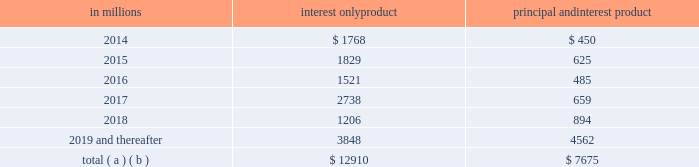Charge-off is based on pnc 2019s actual loss experience for each type of pool .
Since a pool may consist of first and second liens , the charge-off amounts for the pool are proportionate to the composition of first and second liens in the pool .
Our experience has been that the ratio of first to second lien loans has been consistent over time and is appropriately represented in our pools used for roll-rate calculations .
Generally , our variable-rate home equity lines of credit have either a seven or ten year draw period , followed by a 20-year amortization term .
During the draw period , we have home equity lines of credit where borrowers pay interest only and home equity lines of credit where borrowers pay principal and interest .
The risk associated with our home equity lines of credit end of period draw dates is considered in establishing our alll .
Based upon outstanding balances at december 31 , 2013 , the table presents the periods when home equity lines of credit draw periods are scheduled to end .
Table 41 : home equity lines of credit 2013 draw period end in millions interest only product principal and interest product .
( a ) includes all home equity lines of credit that mature in 2014 or later , including those with borrowers where we have terminated borrowing privileges .
( b ) includes approximately $ 185 million , $ 193 million , $ 54 million , $ 63 million , $ 47 million and $ 561 million of home equity lines of credit with balloon payments , including those where we have terminated borrowing privileges , with draw periods scheduled to end in 2014 , 2015 , 2016 , 2017 , 2018 and 2019 and thereafter , respectively .
We view home equity lines of credit where borrowers are paying principal and interest under the draw period as less risky than those where the borrowers are paying interest only , as these borrowers have a demonstrated ability to make some level of principal and interest payments .
Based upon outstanding balances , and excluding purchased impaired loans , at december 31 , 2013 , for home equity lines of credit for which the borrower can no longer draw ( e.g. , draw period has ended or borrowing privileges have been terminated ) , approximately 3.65% ( 3.65 % ) were 30-89 days past due and approximately 5.49% ( 5.49 % ) were 90 days or more past due .
Generally , when a borrower becomes 60 days past due , we terminate borrowing privileges and those privileges are not subsequently reinstated .
At that point , we continue our collection/recovery processes , which may include a loss mitigation loan modification resulting in a loan that is classified as a tdr .
See note 5 asset quality in the notes to consolidated financial statements in item 8 of this report for additional information .
Loan modifications and troubled debt restructurings consumer loan modifications we modify loans under government and pnc-developed programs based upon our commitment to help eligible homeowners and borrowers avoid foreclosure , where appropriate .
Initially , a borrower is evaluated for a modification under a government program .
If a borrower does not qualify under a government program , the borrower is then evaluated under a pnc program .
Our programs utilize both temporary and permanent modifications and typically reduce the interest rate , extend the term and/or defer principal .
Temporary and permanent modifications under programs involving a change to loan terms are generally classified as tdrs .
Further , certain payment plans and trial payment arrangements which do not include a contractual change to loan terms may be classified as tdrs .
Additional detail on tdrs is discussed below as well as in note 5 asset quality in the notes to consolidated financial statements in item 8 of this report .
A temporary modification , with a term between 3 and 24 months , involves a change in original loan terms for a period of time and reverts to a calculated exit rate for the remaining term of the loan as of a specific date .
A permanent modification , with a term greater than 24 months , is a modification in which the terms of the original loan are changed .
Permanent modifications primarily include the government-created home affordable modification program ( hamp ) or pnc-developed hamp-like modification programs .
For home equity lines of credit , we will enter into a temporary modification when the borrower has indicated a temporary hardship and a willingness to bring current the delinquent loan balance .
Examples of this situation often include delinquency due to illness or death in the family or loss of employment .
Permanent modifications are entered into when it is confirmed that the borrower does not possess the income necessary to continue making loan payments at the current amount , but our expectation is that payments at lower amounts can be made .
We also monitor the success rates and delinquency status of our loan modification programs to assess their effectiveness in serving our customers 2019 needs while mitigating credit losses .
Table 42 provides the number of accounts and unpaid principal balance of modified consumer real estate related loans and table 43 provides the number of accounts and unpaid principal balance of modified loans that were 60 days or more past due as of six months , nine months , twelve months and fifteen months after the modification date .
The pnc financial services group , inc .
2013 form 10-k 79 .
For the 2014 draw period balances of interest only products , what percent were home equity lines of credit with balloon payments , including those where we have terminated borrowing privileges? 
Computations: (185 / 1768)
Answer: 0.10464. 